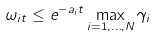Convert formula to latex. <formula><loc_0><loc_0><loc_500><loc_500>\omega _ { i t } \leq e ^ { - a _ { i } t } \max _ { i = 1 , \dots , N } \gamma _ { i }</formula> 